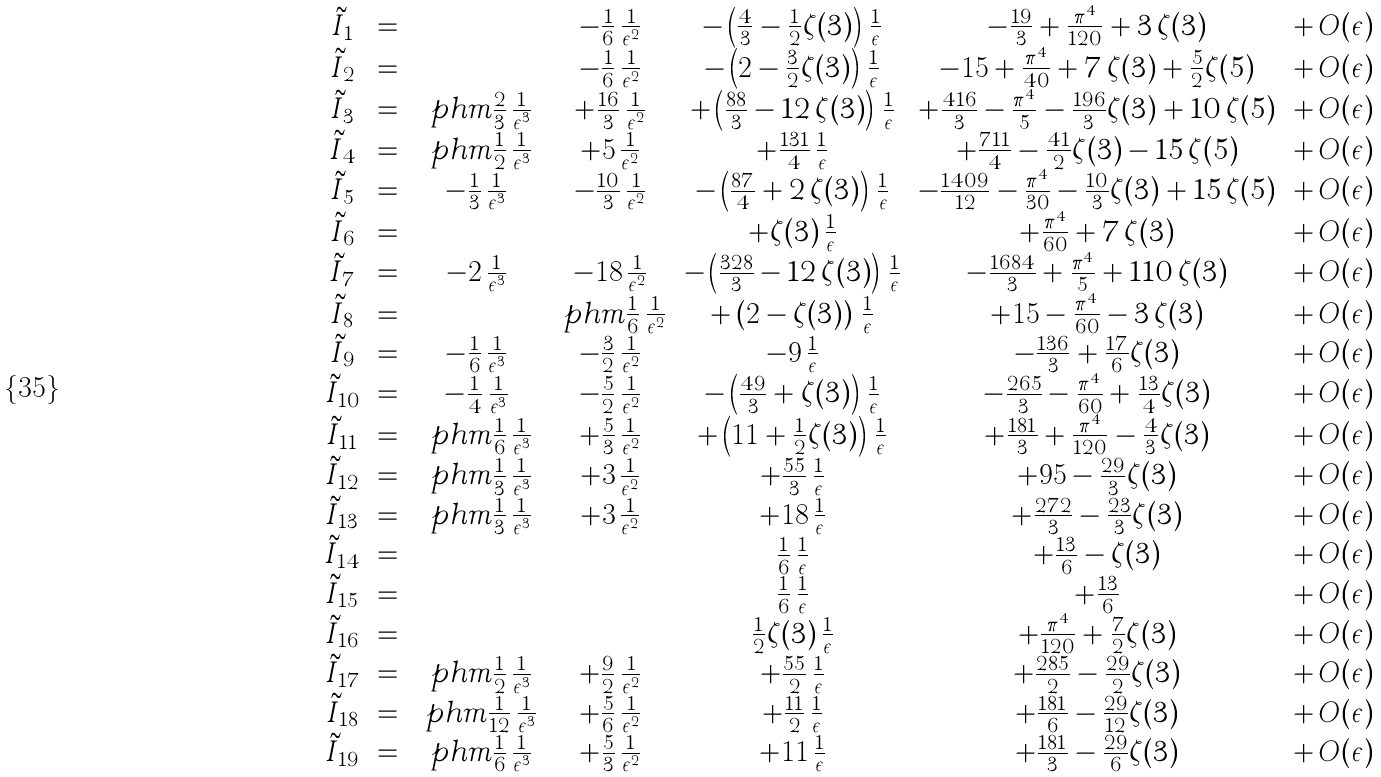Convert formula to latex. <formula><loc_0><loc_0><loc_500><loc_500>\begin{array} { c c c c c c c } \tilde { I } _ { 1 } & = & & - \frac { 1 } { 6 } \, \frac { 1 } { \epsilon ^ { 2 } } & - \left ( \frac { 4 } { 3 } - \frac { 1 } { 2 } { \text {$\zeta(3)$} } \right ) \, \frac { 1 } { \epsilon } & - \frac { 1 9 } { 3 } + \frac { \pi ^ { 4 } } { 1 2 0 } + { \text {$3 \, \zeta(3)$} } & + \, O ( \epsilon ) \\ \tilde { I } _ { 2 } & = & & - \frac { 1 } { 6 } \, \frac { 1 } { \epsilon ^ { 2 } } & - \left ( { \text {2} } - \frac { 3 } { 2 } { \text {$\zeta(3)$} } \right ) \, \frac { 1 } { \epsilon } & - { \text {15} } + \frac { \pi ^ { 4 } } { 4 0 } + { \text {$7 \, \zeta(3)$} } + \frac { 5 } { 2 } { \text {$\zeta(5)$} } & + \, O ( \epsilon ) \\ \tilde { I } _ { 3 } & = & \ p h m \frac { 2 } { 3 } \, \frac { 1 } { \epsilon ^ { 3 } } & + \frac { 1 6 } { 3 } \, \frac { 1 } { \epsilon ^ { 2 } } & + \left ( \frac { 8 8 } { 3 } - { \text {$12 \, \zeta(3)$} } \right ) \, \frac { 1 } { \epsilon } & + \frac { 4 1 6 } { 3 } - \frac { \pi ^ { 4 } } { 5 } - \frac { 1 9 6 } { 3 } { \text {$\zeta(3)$} } + { \text {$10 \,    \zeta(5)$} } & + \, O ( \epsilon ) \\ \tilde { I } _ { 4 } & = & \ p h m \frac { 1 } { 2 } \, \frac { 1 } { \epsilon ^ { 3 } } & + { \text {5} } \, \frac { 1 } { \epsilon ^ { 2 } } & + \frac { 1 3 1 } { 4 } \, \frac { 1 } { \epsilon } & + \frac { 7 1 1 } { 4 } - \frac { 4 1 } { 2 } { \text {$\zeta(3)$} } - { \text {$15 \, \zeta(5)$} } & + \, O ( \epsilon ) \\ \tilde { I } _ { 5 } & = & - \frac { 1 } { 3 } \, \frac { 1 } { \epsilon ^ { 3 } } & - \frac { 1 0 } { 3 } \, \frac { 1 } { \epsilon ^ { 2 } } & - \left ( \frac { 8 7 } { 4 } + { \text {$2 \, \zeta(3)$} } \right ) \, \frac { 1 } { \epsilon } & - \frac { 1 4 0 9 } { 1 2 } - \frac { \pi ^ { 4 } } { 3 0 } - \frac { 1 0 } { 3 } { \text {$\zeta(3)$} } + { \text {$15 \, \zeta(5)$} } & + \, O ( \epsilon ) \\ \tilde { I } _ { 6 } & = & & & + { \text {$\zeta(3)$} } \, \frac { 1 } { \epsilon } & + \frac { \pi ^ { 4 } } { 6 0 } + { \text {$7 \,    \zeta(3)$} } & + \, O ( \epsilon ) \\ \tilde { I } _ { 7 } & = & - { \text {2} } \, \frac { 1 } { \epsilon ^ { 3 } } & - { \text {18} } \, \frac { 1 } { \epsilon ^ { 2 } } & - \left ( \frac { 3 2 8 } { 3 } - { \text {$12 \, \zeta(3)$} } \right ) \, \frac { 1 } { \epsilon } & - \frac { 1 6 8 4 } { 3 } + \frac { \pi ^ { 4 } } { 5 } + { \text {$110 \, \zeta(3)$} } & + \, O ( \epsilon ) \\ \tilde { I } _ { 8 } & = & & \ p h m \frac { 1 } { 6 } \, \frac { 1 } { \epsilon ^ { 2 } } & + \left ( { \text {2} } - { \text {$\zeta(3)$} } \right ) \, \frac { 1 } { \epsilon } & + { \text {15} } - \frac { \pi ^ { 4 } } { 6 0 } - { \text {$3 \, \zeta(3)$} } & + \, O ( \epsilon ) \\ \tilde { I } _ { 9 } & = & - \frac { 1 } { 6 } \, \frac { 1 } { \epsilon ^ { 3 } } & - \frac { 3 } { 2 } \, \frac { 1 } { \epsilon ^ { 2 } } & - { \text {9} } \, \frac { 1 } { \epsilon } & - \frac { 1 3 6 } { 3 } + \frac { 1 7 } { 6 } { \text {$\zeta(3)$} } & + \, O ( \epsilon ) \\ \tilde { I } _ { 1 0 } & = & - \frac { 1 } { 4 } \, \frac { 1 } { \epsilon ^ { 3 } } & - \frac { 5 } { 2 } \, \frac { 1 } { \epsilon ^ { 2 } } & - \left ( \frac { 4 9 } { 3 } + { \text {$\zeta(3)$} } \right ) \, \frac { 1 } { \epsilon } & - \frac { 2 6 5 } { 3 } - \frac { \pi ^ { 4 } } { 6 0 } + \frac { 1 3 } { 4 } { \text {$\zeta(3)$} } & + \, O ( \epsilon ) \\ \tilde { I } _ { 1 1 } & = & \ p h m \frac { 1 } { 6 } \, \frac { 1 } { \epsilon ^ { 3 } } & + \frac { 5 } { 3 } \, \frac { 1 } { \epsilon ^ { 2 } } & + \left ( { \text {11} } + \frac { 1 } { 2 } { \text {$\zeta(3)$} } \right ) \, \frac { 1 } { \epsilon } & + \frac { 1 8 1 } { 3 } + \frac { \pi ^ { 4 } } { 1 2 0 } - \frac { 4 } { 3 } { \text {$\zeta(3)$} } & + \, O ( \epsilon ) \\ \tilde { I } _ { 1 2 } & = & \ p h m \frac { 1 } { 3 } \, \frac { 1 } { \epsilon ^ { 3 } } & + { \text {3} } \, \frac { 1 } { \epsilon ^ { 2 } } & + \frac { 5 5 } { 3 } \, \frac { 1 } { \epsilon } & + { \text {95} } - \frac { 2 9 } { 3 } { \text {$\zeta(3)$} } & + \, O ( \epsilon ) \\ \tilde { I } _ { 1 3 } & = & \ p h m \frac { 1 } { 3 } \, \frac { 1 } { \epsilon ^ { 3 } } & + { \text {3} } \, \frac { 1 } { \epsilon ^ { 2 } } & + { \text {18} } \, \frac { 1 } { \epsilon } & + \frac { 2 7 2 } { 3 } - \frac { 2 3 } { 3 } { \text {$\zeta(3)$} } & + \, O ( \epsilon ) \\ \tilde { I } _ { 1 4 } & = & & & \frac { 1 } { 6 } \, \frac { 1 } { \epsilon } & + \frac { 1 3 } { 6 } - { \text {$\zeta(3)$} } & + \, O ( \epsilon ) \\ \tilde { I } _ { 1 5 } & = & & & \frac { 1 } { 6 } \, \frac { 1 } { \epsilon } & + \frac { 1 3 } { 6 } & + \, O ( \epsilon ) \\ \tilde { I } _ { 1 6 } & = & & & \frac { 1 } { 2 } { \text {$\zeta(3)$} } \, \frac { 1 } { \epsilon } & + \frac { \pi ^ { 4 } } { 1 2 0 } + \frac { 7 } { 2 } { \text {$\zeta(3)$} } & + \, O ( \epsilon ) \\ \tilde { I } _ { 1 7 } & = & \ p h m \frac { 1 } { 2 } \, \frac { 1 } { \epsilon ^ { 3 } } & + \frac { 9 } { 2 } \, \frac { 1 } { \epsilon ^ { 2 } } & + \frac { 5 5 } { 2 } \, \frac { 1 } { \epsilon } & + \frac { 2 8 5 } { 2 } - \frac { 2 9 } { 2 } { \text {$\zeta(3)$} } & + \, O ( \epsilon ) \\ \tilde { I } _ { 1 8 } & = & \ p h m \frac { 1 } { 1 2 } \, \frac { 1 } { \epsilon ^ { 3 } } & + \frac { 5 } { 6 } \, \frac { 1 } { \epsilon ^ { 2 } } & + \frac { 1 1 } { 2 } \, \frac { 1 } { \epsilon } & + \frac { 1 8 1 } { 6 } - \frac { 2 9 } { 1 2 } { \text {$\zeta(3)$} } & + \, O ( \epsilon ) \\ \tilde { I } _ { 1 9 } & = & \ p h m \frac { 1 } { 6 } \, \frac { 1 } { \epsilon ^ { 3 } } & + \frac { 5 } { 3 } \, \frac { 1 } { \epsilon ^ { 2 } } & + { \text {11} } \, \frac { 1 } { \epsilon } & + \frac { 1 8 1 } { 3 } - \frac { 2 9 } { 6 } { \text {$\zeta(3)$} } & + \, O ( \epsilon ) \end{array}</formula> 